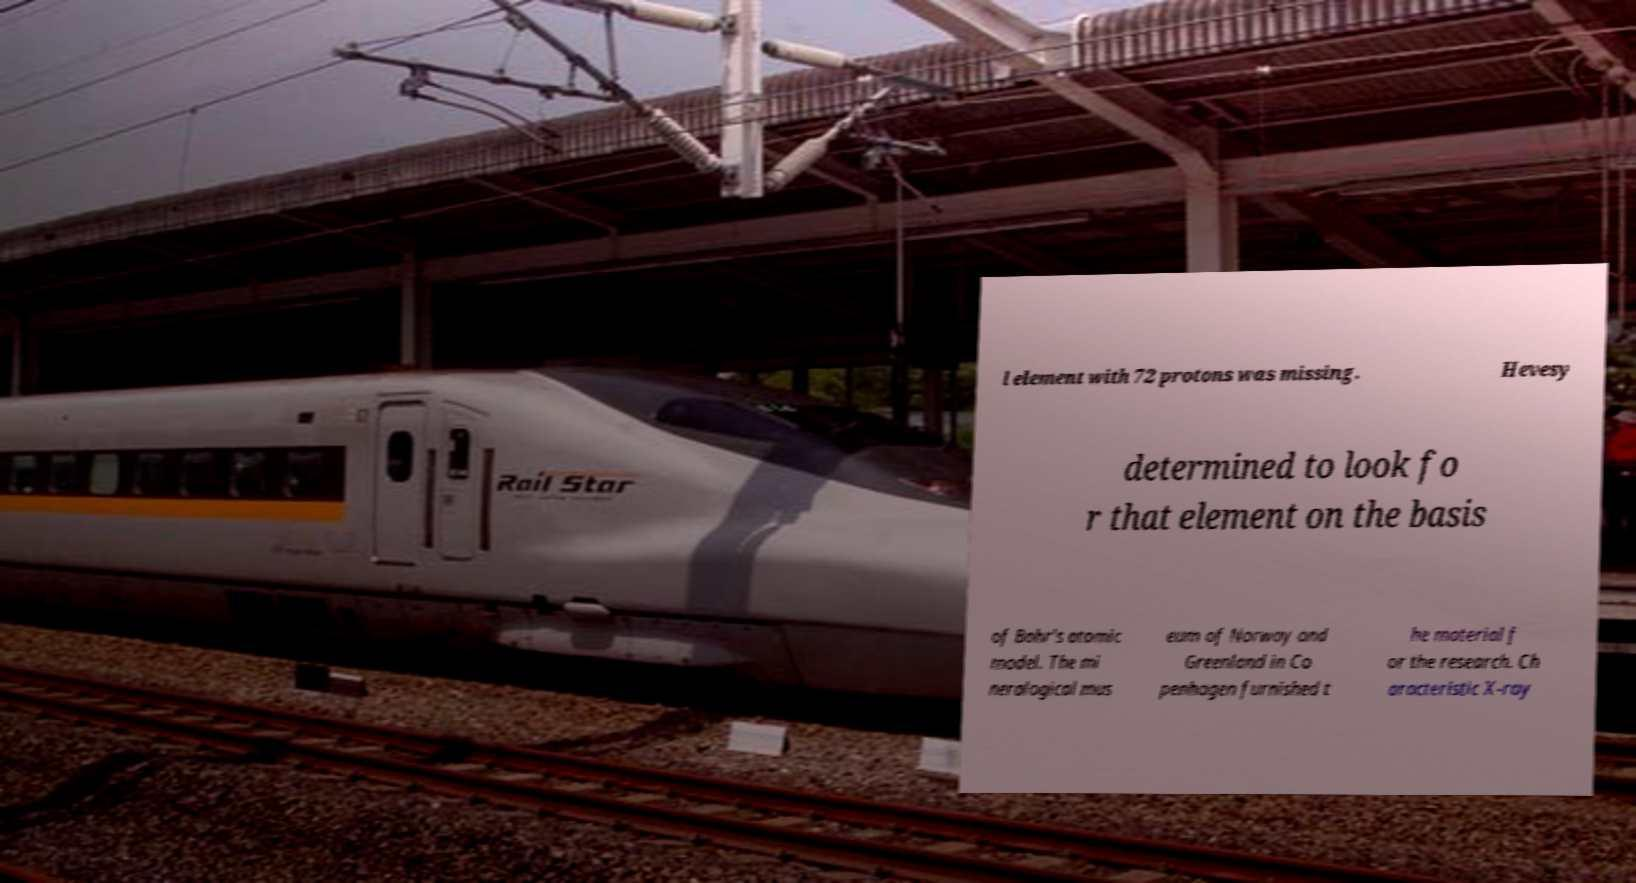There's text embedded in this image that I need extracted. Can you transcribe it verbatim? l element with 72 protons was missing. Hevesy determined to look fo r that element on the basis of Bohr's atomic model. The mi neralogical mus eum of Norway and Greenland in Co penhagen furnished t he material f or the research. Ch aracteristic X-ray 